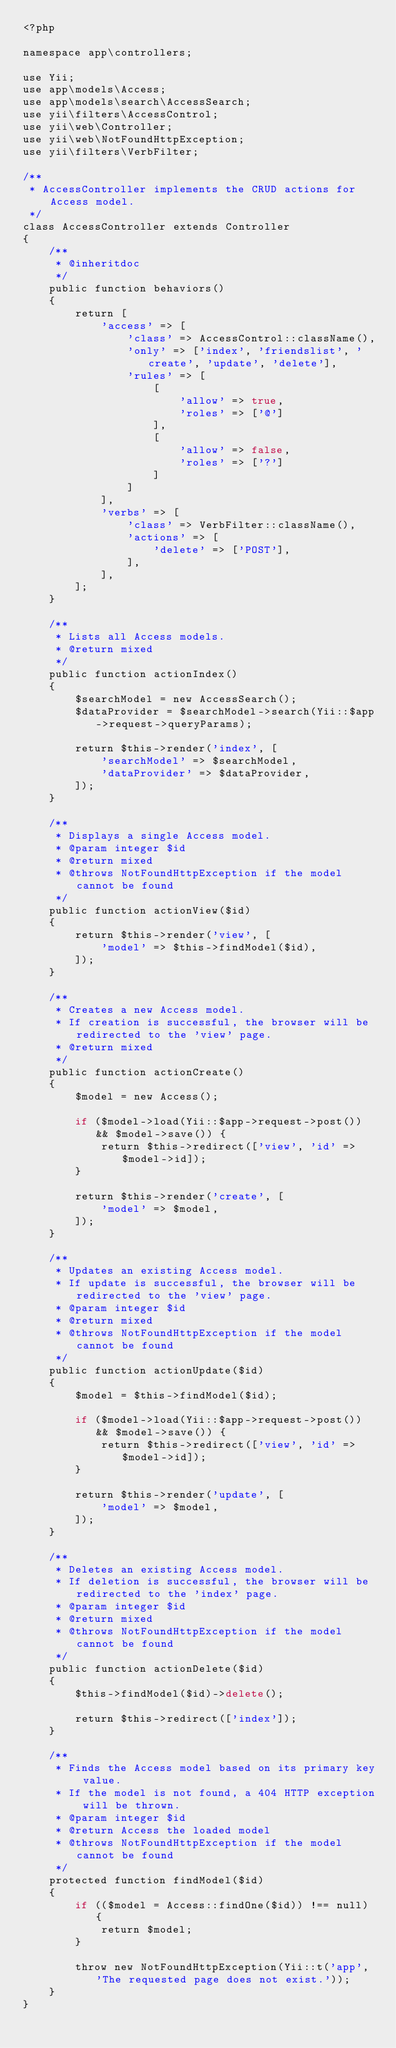Convert code to text. <code><loc_0><loc_0><loc_500><loc_500><_PHP_><?php

namespace app\controllers;

use Yii;
use app\models\Access;
use app\models\search\AccessSearch;
use yii\filters\AccessControl;
use yii\web\Controller;
use yii\web\NotFoundHttpException;
use yii\filters\VerbFilter;

/**
 * AccessController implements the CRUD actions for Access model.
 */
class AccessController extends Controller
{
    /**
     * @inheritdoc
     */
    public function behaviors()
    {
        return [
            'access' => [
                'class' => AccessControl::className(),
                'only' => ['index', 'friendslist', 'create', 'update', 'delete'],
                'rules' => [
                    [
                        'allow' => true,
                        'roles' => ['@']
                    ],
                    [
                        'allow' => false,
                        'roles' => ['?']
                    ]
                ]
            ],
            'verbs' => [
                'class' => VerbFilter::className(),
                'actions' => [
                    'delete' => ['POST'],
                ],
            ],
        ];
    }

    /**
     * Lists all Access models.
     * @return mixed
     */
    public function actionIndex()
    {
        $searchModel = new AccessSearch();
        $dataProvider = $searchModel->search(Yii::$app->request->queryParams);

        return $this->render('index', [
            'searchModel' => $searchModel,
            'dataProvider' => $dataProvider,
        ]);
    }

    /**
     * Displays a single Access model.
     * @param integer $id
     * @return mixed
     * @throws NotFoundHttpException if the model cannot be found
     */
    public function actionView($id)
    {
        return $this->render('view', [
            'model' => $this->findModel($id),
        ]);
    }

    /**
     * Creates a new Access model.
     * If creation is successful, the browser will be redirected to the 'view' page.
     * @return mixed
     */
    public function actionCreate()
    {
        $model = new Access();

        if ($model->load(Yii::$app->request->post()) && $model->save()) {
            return $this->redirect(['view', 'id' => $model->id]);
        }

        return $this->render('create', [
            'model' => $model,
        ]);
    }

    /**
     * Updates an existing Access model.
     * If update is successful, the browser will be redirected to the 'view' page.
     * @param integer $id
     * @return mixed
     * @throws NotFoundHttpException if the model cannot be found
     */
    public function actionUpdate($id)
    {
        $model = $this->findModel($id);

        if ($model->load(Yii::$app->request->post()) && $model->save()) {
            return $this->redirect(['view', 'id' => $model->id]);
        }

        return $this->render('update', [
            'model' => $model,
        ]);
    }

    /**
     * Deletes an existing Access model.
     * If deletion is successful, the browser will be redirected to the 'index' page.
     * @param integer $id
     * @return mixed
     * @throws NotFoundHttpException if the model cannot be found
     */
    public function actionDelete($id)
    {
        $this->findModel($id)->delete();

        return $this->redirect(['index']);
    }

    /**
     * Finds the Access model based on its primary key value.
     * If the model is not found, a 404 HTTP exception will be thrown.
     * @param integer $id
     * @return Access the loaded model
     * @throws NotFoundHttpException if the model cannot be found
     */
    protected function findModel($id)
    {
        if (($model = Access::findOne($id)) !== null) {
            return $model;
        }

        throw new NotFoundHttpException(Yii::t('app', 'The requested page does not exist.'));
    }
}
</code> 